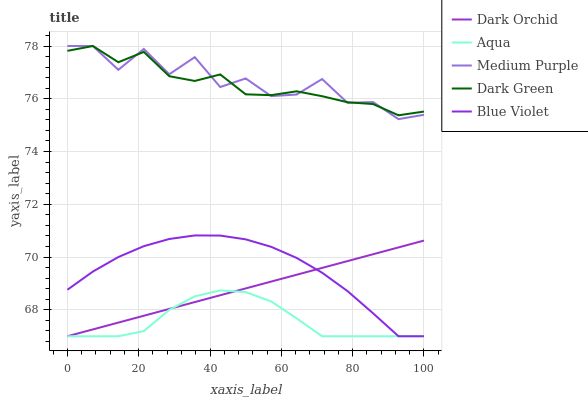Does Aqua have the minimum area under the curve?
Answer yes or no. Yes. Does Medium Purple have the maximum area under the curve?
Answer yes or no. Yes. Does Blue Violet have the minimum area under the curve?
Answer yes or no. No. Does Blue Violet have the maximum area under the curve?
Answer yes or no. No. Is Dark Orchid the smoothest?
Answer yes or no. Yes. Is Medium Purple the roughest?
Answer yes or no. Yes. Is Aqua the smoothest?
Answer yes or no. No. Is Aqua the roughest?
Answer yes or no. No. Does Aqua have the lowest value?
Answer yes or no. Yes. Does Dark Green have the lowest value?
Answer yes or no. No. Does Dark Green have the highest value?
Answer yes or no. Yes. Does Blue Violet have the highest value?
Answer yes or no. No. Is Aqua less than Dark Green?
Answer yes or no. Yes. Is Medium Purple greater than Dark Orchid?
Answer yes or no. Yes. Does Aqua intersect Blue Violet?
Answer yes or no. Yes. Is Aqua less than Blue Violet?
Answer yes or no. No. Is Aqua greater than Blue Violet?
Answer yes or no. No. Does Aqua intersect Dark Green?
Answer yes or no. No. 